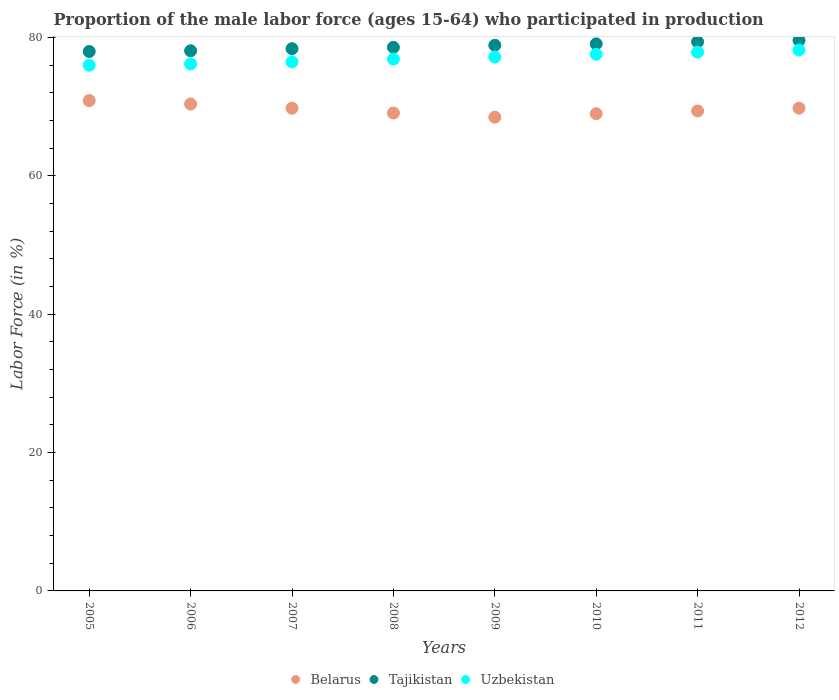What is the proportion of the male labor force who participated in production in Uzbekistan in 2011?
Offer a terse response. 77.9. Across all years, what is the maximum proportion of the male labor force who participated in production in Tajikistan?
Provide a short and direct response. 79.6. Across all years, what is the minimum proportion of the male labor force who participated in production in Belarus?
Provide a short and direct response. 68.5. In which year was the proportion of the male labor force who participated in production in Uzbekistan maximum?
Keep it short and to the point. 2012. In which year was the proportion of the male labor force who participated in production in Tajikistan minimum?
Offer a terse response. 2005. What is the total proportion of the male labor force who participated in production in Belarus in the graph?
Keep it short and to the point. 556.9. What is the difference between the proportion of the male labor force who participated in production in Belarus in 2006 and the proportion of the male labor force who participated in production in Uzbekistan in 2005?
Give a very brief answer. -5.6. What is the average proportion of the male labor force who participated in production in Uzbekistan per year?
Give a very brief answer. 77.06. In the year 2012, what is the difference between the proportion of the male labor force who participated in production in Belarus and proportion of the male labor force who participated in production in Tajikistan?
Provide a short and direct response. -9.8. In how many years, is the proportion of the male labor force who participated in production in Uzbekistan greater than 20 %?
Your answer should be compact. 8. What is the ratio of the proportion of the male labor force who participated in production in Belarus in 2006 to that in 2009?
Your answer should be very brief. 1.03. What is the difference between the highest and the second highest proportion of the male labor force who participated in production in Belarus?
Your response must be concise. 0.5. What is the difference between the highest and the lowest proportion of the male labor force who participated in production in Tajikistan?
Ensure brevity in your answer.  1.6. Is the proportion of the male labor force who participated in production in Belarus strictly less than the proportion of the male labor force who participated in production in Uzbekistan over the years?
Make the answer very short. Yes. How many dotlines are there?
Provide a succinct answer. 3. Does the graph contain grids?
Keep it short and to the point. No. Where does the legend appear in the graph?
Give a very brief answer. Bottom center. What is the title of the graph?
Provide a succinct answer. Proportion of the male labor force (ages 15-64) who participated in production. Does "Azerbaijan" appear as one of the legend labels in the graph?
Your response must be concise. No. What is the label or title of the X-axis?
Ensure brevity in your answer.  Years. What is the Labor Force (in %) in Belarus in 2005?
Offer a very short reply. 70.9. What is the Labor Force (in %) of Tajikistan in 2005?
Your response must be concise. 78. What is the Labor Force (in %) of Belarus in 2006?
Your answer should be very brief. 70.4. What is the Labor Force (in %) in Tajikistan in 2006?
Make the answer very short. 78.1. What is the Labor Force (in %) of Uzbekistan in 2006?
Your answer should be compact. 76.2. What is the Labor Force (in %) of Belarus in 2007?
Ensure brevity in your answer.  69.8. What is the Labor Force (in %) in Tajikistan in 2007?
Ensure brevity in your answer.  78.4. What is the Labor Force (in %) of Uzbekistan in 2007?
Offer a very short reply. 76.5. What is the Labor Force (in %) of Belarus in 2008?
Ensure brevity in your answer.  69.1. What is the Labor Force (in %) of Tajikistan in 2008?
Offer a very short reply. 78.6. What is the Labor Force (in %) in Uzbekistan in 2008?
Give a very brief answer. 76.9. What is the Labor Force (in %) of Belarus in 2009?
Give a very brief answer. 68.5. What is the Labor Force (in %) in Tajikistan in 2009?
Your answer should be very brief. 78.9. What is the Labor Force (in %) of Uzbekistan in 2009?
Your answer should be very brief. 77.2. What is the Labor Force (in %) of Tajikistan in 2010?
Make the answer very short. 79.1. What is the Labor Force (in %) in Uzbekistan in 2010?
Keep it short and to the point. 77.6. What is the Labor Force (in %) of Belarus in 2011?
Your response must be concise. 69.4. What is the Labor Force (in %) of Tajikistan in 2011?
Your answer should be very brief. 79.4. What is the Labor Force (in %) in Uzbekistan in 2011?
Make the answer very short. 77.9. What is the Labor Force (in %) of Belarus in 2012?
Provide a short and direct response. 69.8. What is the Labor Force (in %) in Tajikistan in 2012?
Provide a succinct answer. 79.6. What is the Labor Force (in %) of Uzbekistan in 2012?
Your answer should be very brief. 78.2. Across all years, what is the maximum Labor Force (in %) of Belarus?
Offer a terse response. 70.9. Across all years, what is the maximum Labor Force (in %) of Tajikistan?
Offer a very short reply. 79.6. Across all years, what is the maximum Labor Force (in %) of Uzbekistan?
Make the answer very short. 78.2. Across all years, what is the minimum Labor Force (in %) in Belarus?
Keep it short and to the point. 68.5. Across all years, what is the minimum Labor Force (in %) in Tajikistan?
Give a very brief answer. 78. What is the total Labor Force (in %) of Belarus in the graph?
Your response must be concise. 556.9. What is the total Labor Force (in %) in Tajikistan in the graph?
Your answer should be very brief. 630.1. What is the total Labor Force (in %) of Uzbekistan in the graph?
Your answer should be compact. 616.5. What is the difference between the Labor Force (in %) in Belarus in 2005 and that in 2006?
Your response must be concise. 0.5. What is the difference between the Labor Force (in %) of Tajikistan in 2005 and that in 2006?
Provide a succinct answer. -0.1. What is the difference between the Labor Force (in %) in Uzbekistan in 2005 and that in 2006?
Your answer should be compact. -0.2. What is the difference between the Labor Force (in %) of Belarus in 2005 and that in 2007?
Your answer should be compact. 1.1. What is the difference between the Labor Force (in %) in Uzbekistan in 2005 and that in 2007?
Your answer should be compact. -0.5. What is the difference between the Labor Force (in %) of Belarus in 2005 and that in 2009?
Offer a very short reply. 2.4. What is the difference between the Labor Force (in %) of Tajikistan in 2005 and that in 2009?
Your response must be concise. -0.9. What is the difference between the Labor Force (in %) in Belarus in 2005 and that in 2010?
Your response must be concise. 1.9. What is the difference between the Labor Force (in %) of Uzbekistan in 2005 and that in 2010?
Your answer should be very brief. -1.6. What is the difference between the Labor Force (in %) in Belarus in 2005 and that in 2011?
Ensure brevity in your answer.  1.5. What is the difference between the Labor Force (in %) of Tajikistan in 2005 and that in 2011?
Provide a succinct answer. -1.4. What is the difference between the Labor Force (in %) of Tajikistan in 2005 and that in 2012?
Make the answer very short. -1.6. What is the difference between the Labor Force (in %) of Uzbekistan in 2005 and that in 2012?
Ensure brevity in your answer.  -2.2. What is the difference between the Labor Force (in %) in Uzbekistan in 2006 and that in 2007?
Your response must be concise. -0.3. What is the difference between the Labor Force (in %) of Belarus in 2006 and that in 2008?
Make the answer very short. 1.3. What is the difference between the Labor Force (in %) of Tajikistan in 2006 and that in 2008?
Ensure brevity in your answer.  -0.5. What is the difference between the Labor Force (in %) of Uzbekistan in 2006 and that in 2009?
Your answer should be compact. -1. What is the difference between the Labor Force (in %) of Tajikistan in 2006 and that in 2010?
Give a very brief answer. -1. What is the difference between the Labor Force (in %) of Belarus in 2006 and that in 2011?
Make the answer very short. 1. What is the difference between the Labor Force (in %) of Uzbekistan in 2006 and that in 2011?
Offer a very short reply. -1.7. What is the difference between the Labor Force (in %) in Tajikistan in 2006 and that in 2012?
Give a very brief answer. -1.5. What is the difference between the Labor Force (in %) of Belarus in 2007 and that in 2008?
Your response must be concise. 0.7. What is the difference between the Labor Force (in %) of Uzbekistan in 2007 and that in 2008?
Offer a terse response. -0.4. What is the difference between the Labor Force (in %) of Tajikistan in 2007 and that in 2009?
Your answer should be very brief. -0.5. What is the difference between the Labor Force (in %) of Uzbekistan in 2007 and that in 2009?
Your answer should be very brief. -0.7. What is the difference between the Labor Force (in %) in Tajikistan in 2007 and that in 2010?
Make the answer very short. -0.7. What is the difference between the Labor Force (in %) in Uzbekistan in 2007 and that in 2010?
Your response must be concise. -1.1. What is the difference between the Labor Force (in %) in Uzbekistan in 2007 and that in 2011?
Make the answer very short. -1.4. What is the difference between the Labor Force (in %) of Uzbekistan in 2007 and that in 2012?
Offer a terse response. -1.7. What is the difference between the Labor Force (in %) of Tajikistan in 2008 and that in 2009?
Offer a very short reply. -0.3. What is the difference between the Labor Force (in %) of Belarus in 2008 and that in 2010?
Give a very brief answer. 0.1. What is the difference between the Labor Force (in %) in Tajikistan in 2008 and that in 2010?
Your answer should be compact. -0.5. What is the difference between the Labor Force (in %) in Tajikistan in 2008 and that in 2011?
Ensure brevity in your answer.  -0.8. What is the difference between the Labor Force (in %) in Uzbekistan in 2008 and that in 2012?
Keep it short and to the point. -1.3. What is the difference between the Labor Force (in %) in Belarus in 2009 and that in 2011?
Offer a very short reply. -0.9. What is the difference between the Labor Force (in %) in Tajikistan in 2009 and that in 2011?
Provide a short and direct response. -0.5. What is the difference between the Labor Force (in %) of Uzbekistan in 2009 and that in 2011?
Keep it short and to the point. -0.7. What is the difference between the Labor Force (in %) of Belarus in 2009 and that in 2012?
Offer a very short reply. -1.3. What is the difference between the Labor Force (in %) of Uzbekistan in 2010 and that in 2011?
Provide a succinct answer. -0.3. What is the difference between the Labor Force (in %) of Belarus in 2010 and that in 2012?
Give a very brief answer. -0.8. What is the difference between the Labor Force (in %) of Uzbekistan in 2010 and that in 2012?
Make the answer very short. -0.6. What is the difference between the Labor Force (in %) in Tajikistan in 2011 and that in 2012?
Your response must be concise. -0.2. What is the difference between the Labor Force (in %) of Uzbekistan in 2011 and that in 2012?
Offer a terse response. -0.3. What is the difference between the Labor Force (in %) of Belarus in 2005 and the Labor Force (in %) of Uzbekistan in 2006?
Make the answer very short. -5.3. What is the difference between the Labor Force (in %) in Belarus in 2005 and the Labor Force (in %) in Tajikistan in 2007?
Make the answer very short. -7.5. What is the difference between the Labor Force (in %) in Tajikistan in 2005 and the Labor Force (in %) in Uzbekistan in 2007?
Provide a short and direct response. 1.5. What is the difference between the Labor Force (in %) in Belarus in 2005 and the Labor Force (in %) in Tajikistan in 2008?
Make the answer very short. -7.7. What is the difference between the Labor Force (in %) in Belarus in 2005 and the Labor Force (in %) in Uzbekistan in 2008?
Keep it short and to the point. -6. What is the difference between the Labor Force (in %) of Belarus in 2005 and the Labor Force (in %) of Tajikistan in 2010?
Make the answer very short. -8.2. What is the difference between the Labor Force (in %) in Belarus in 2005 and the Labor Force (in %) in Uzbekistan in 2010?
Ensure brevity in your answer.  -6.7. What is the difference between the Labor Force (in %) of Tajikistan in 2005 and the Labor Force (in %) of Uzbekistan in 2010?
Provide a succinct answer. 0.4. What is the difference between the Labor Force (in %) in Belarus in 2005 and the Labor Force (in %) in Tajikistan in 2011?
Provide a short and direct response. -8.5. What is the difference between the Labor Force (in %) in Belarus in 2005 and the Labor Force (in %) in Tajikistan in 2012?
Provide a short and direct response. -8.7. What is the difference between the Labor Force (in %) in Belarus in 2005 and the Labor Force (in %) in Uzbekistan in 2012?
Keep it short and to the point. -7.3. What is the difference between the Labor Force (in %) in Tajikistan in 2006 and the Labor Force (in %) in Uzbekistan in 2008?
Make the answer very short. 1.2. What is the difference between the Labor Force (in %) in Tajikistan in 2006 and the Labor Force (in %) in Uzbekistan in 2009?
Give a very brief answer. 0.9. What is the difference between the Labor Force (in %) of Belarus in 2006 and the Labor Force (in %) of Tajikistan in 2010?
Offer a terse response. -8.7. What is the difference between the Labor Force (in %) of Belarus in 2006 and the Labor Force (in %) of Uzbekistan in 2010?
Provide a succinct answer. -7.2. What is the difference between the Labor Force (in %) of Belarus in 2006 and the Labor Force (in %) of Tajikistan in 2011?
Ensure brevity in your answer.  -9. What is the difference between the Labor Force (in %) of Tajikistan in 2006 and the Labor Force (in %) of Uzbekistan in 2011?
Provide a succinct answer. 0.2. What is the difference between the Labor Force (in %) of Tajikistan in 2006 and the Labor Force (in %) of Uzbekistan in 2012?
Your answer should be compact. -0.1. What is the difference between the Labor Force (in %) of Belarus in 2007 and the Labor Force (in %) of Tajikistan in 2008?
Your answer should be compact. -8.8. What is the difference between the Labor Force (in %) in Belarus in 2007 and the Labor Force (in %) in Tajikistan in 2009?
Your response must be concise. -9.1. What is the difference between the Labor Force (in %) of Tajikistan in 2007 and the Labor Force (in %) of Uzbekistan in 2009?
Provide a succinct answer. 1.2. What is the difference between the Labor Force (in %) of Belarus in 2007 and the Labor Force (in %) of Uzbekistan in 2010?
Your answer should be compact. -7.8. What is the difference between the Labor Force (in %) in Tajikistan in 2007 and the Labor Force (in %) in Uzbekistan in 2010?
Give a very brief answer. 0.8. What is the difference between the Labor Force (in %) in Belarus in 2007 and the Labor Force (in %) in Tajikistan in 2011?
Your answer should be very brief. -9.6. What is the difference between the Labor Force (in %) of Belarus in 2007 and the Labor Force (in %) of Uzbekistan in 2011?
Make the answer very short. -8.1. What is the difference between the Labor Force (in %) in Belarus in 2007 and the Labor Force (in %) in Uzbekistan in 2012?
Provide a succinct answer. -8.4. What is the difference between the Labor Force (in %) in Belarus in 2008 and the Labor Force (in %) in Uzbekistan in 2009?
Make the answer very short. -8.1. What is the difference between the Labor Force (in %) in Tajikistan in 2008 and the Labor Force (in %) in Uzbekistan in 2009?
Ensure brevity in your answer.  1.4. What is the difference between the Labor Force (in %) in Belarus in 2008 and the Labor Force (in %) in Tajikistan in 2010?
Your answer should be very brief. -10. What is the difference between the Labor Force (in %) in Belarus in 2008 and the Labor Force (in %) in Uzbekistan in 2010?
Keep it short and to the point. -8.5. What is the difference between the Labor Force (in %) in Tajikistan in 2008 and the Labor Force (in %) in Uzbekistan in 2010?
Provide a succinct answer. 1. What is the difference between the Labor Force (in %) of Tajikistan in 2008 and the Labor Force (in %) of Uzbekistan in 2011?
Your response must be concise. 0.7. What is the difference between the Labor Force (in %) in Belarus in 2008 and the Labor Force (in %) in Tajikistan in 2012?
Your answer should be very brief. -10.5. What is the difference between the Labor Force (in %) of Belarus in 2008 and the Labor Force (in %) of Uzbekistan in 2012?
Offer a terse response. -9.1. What is the difference between the Labor Force (in %) in Belarus in 2009 and the Labor Force (in %) in Uzbekistan in 2010?
Offer a very short reply. -9.1. What is the difference between the Labor Force (in %) of Belarus in 2010 and the Labor Force (in %) of Tajikistan in 2011?
Ensure brevity in your answer.  -10.4. What is the difference between the Labor Force (in %) of Tajikistan in 2010 and the Labor Force (in %) of Uzbekistan in 2011?
Provide a succinct answer. 1.2. What is the difference between the Labor Force (in %) of Tajikistan in 2010 and the Labor Force (in %) of Uzbekistan in 2012?
Provide a short and direct response. 0.9. What is the average Labor Force (in %) in Belarus per year?
Keep it short and to the point. 69.61. What is the average Labor Force (in %) of Tajikistan per year?
Make the answer very short. 78.76. What is the average Labor Force (in %) in Uzbekistan per year?
Offer a very short reply. 77.06. In the year 2005, what is the difference between the Labor Force (in %) in Belarus and Labor Force (in %) in Tajikistan?
Make the answer very short. -7.1. In the year 2005, what is the difference between the Labor Force (in %) in Belarus and Labor Force (in %) in Uzbekistan?
Your response must be concise. -5.1. In the year 2005, what is the difference between the Labor Force (in %) of Tajikistan and Labor Force (in %) of Uzbekistan?
Offer a terse response. 2. In the year 2006, what is the difference between the Labor Force (in %) of Belarus and Labor Force (in %) of Uzbekistan?
Your response must be concise. -5.8. In the year 2007, what is the difference between the Labor Force (in %) in Belarus and Labor Force (in %) in Uzbekistan?
Ensure brevity in your answer.  -6.7. In the year 2007, what is the difference between the Labor Force (in %) in Tajikistan and Labor Force (in %) in Uzbekistan?
Offer a very short reply. 1.9. In the year 2008, what is the difference between the Labor Force (in %) of Belarus and Labor Force (in %) of Uzbekistan?
Offer a very short reply. -7.8. In the year 2008, what is the difference between the Labor Force (in %) of Tajikistan and Labor Force (in %) of Uzbekistan?
Make the answer very short. 1.7. In the year 2009, what is the difference between the Labor Force (in %) in Tajikistan and Labor Force (in %) in Uzbekistan?
Offer a terse response. 1.7. In the year 2010, what is the difference between the Labor Force (in %) in Belarus and Labor Force (in %) in Tajikistan?
Provide a succinct answer. -10.1. In the year 2010, what is the difference between the Labor Force (in %) in Belarus and Labor Force (in %) in Uzbekistan?
Keep it short and to the point. -8.6. In the year 2011, what is the difference between the Labor Force (in %) of Tajikistan and Labor Force (in %) of Uzbekistan?
Provide a short and direct response. 1.5. What is the ratio of the Labor Force (in %) of Belarus in 2005 to that in 2006?
Offer a very short reply. 1.01. What is the ratio of the Labor Force (in %) in Belarus in 2005 to that in 2007?
Keep it short and to the point. 1.02. What is the ratio of the Labor Force (in %) of Uzbekistan in 2005 to that in 2007?
Provide a succinct answer. 0.99. What is the ratio of the Labor Force (in %) of Belarus in 2005 to that in 2008?
Offer a terse response. 1.03. What is the ratio of the Labor Force (in %) in Uzbekistan in 2005 to that in 2008?
Offer a terse response. 0.99. What is the ratio of the Labor Force (in %) of Belarus in 2005 to that in 2009?
Provide a short and direct response. 1.03. What is the ratio of the Labor Force (in %) of Tajikistan in 2005 to that in 2009?
Offer a very short reply. 0.99. What is the ratio of the Labor Force (in %) in Uzbekistan in 2005 to that in 2009?
Your answer should be very brief. 0.98. What is the ratio of the Labor Force (in %) of Belarus in 2005 to that in 2010?
Give a very brief answer. 1.03. What is the ratio of the Labor Force (in %) in Tajikistan in 2005 to that in 2010?
Your answer should be compact. 0.99. What is the ratio of the Labor Force (in %) of Uzbekistan in 2005 to that in 2010?
Your response must be concise. 0.98. What is the ratio of the Labor Force (in %) of Belarus in 2005 to that in 2011?
Ensure brevity in your answer.  1.02. What is the ratio of the Labor Force (in %) in Tajikistan in 2005 to that in 2011?
Your answer should be compact. 0.98. What is the ratio of the Labor Force (in %) of Uzbekistan in 2005 to that in 2011?
Your answer should be compact. 0.98. What is the ratio of the Labor Force (in %) in Belarus in 2005 to that in 2012?
Offer a very short reply. 1.02. What is the ratio of the Labor Force (in %) of Tajikistan in 2005 to that in 2012?
Give a very brief answer. 0.98. What is the ratio of the Labor Force (in %) of Uzbekistan in 2005 to that in 2012?
Provide a succinct answer. 0.97. What is the ratio of the Labor Force (in %) in Belarus in 2006 to that in 2007?
Your answer should be compact. 1.01. What is the ratio of the Labor Force (in %) in Belarus in 2006 to that in 2008?
Offer a very short reply. 1.02. What is the ratio of the Labor Force (in %) of Uzbekistan in 2006 to that in 2008?
Offer a terse response. 0.99. What is the ratio of the Labor Force (in %) in Belarus in 2006 to that in 2009?
Offer a very short reply. 1.03. What is the ratio of the Labor Force (in %) of Uzbekistan in 2006 to that in 2009?
Ensure brevity in your answer.  0.99. What is the ratio of the Labor Force (in %) of Belarus in 2006 to that in 2010?
Offer a very short reply. 1.02. What is the ratio of the Labor Force (in %) of Tajikistan in 2006 to that in 2010?
Your answer should be compact. 0.99. What is the ratio of the Labor Force (in %) in Belarus in 2006 to that in 2011?
Your answer should be compact. 1.01. What is the ratio of the Labor Force (in %) in Tajikistan in 2006 to that in 2011?
Provide a short and direct response. 0.98. What is the ratio of the Labor Force (in %) of Uzbekistan in 2006 to that in 2011?
Give a very brief answer. 0.98. What is the ratio of the Labor Force (in %) of Belarus in 2006 to that in 2012?
Your answer should be compact. 1.01. What is the ratio of the Labor Force (in %) in Tajikistan in 2006 to that in 2012?
Keep it short and to the point. 0.98. What is the ratio of the Labor Force (in %) in Uzbekistan in 2006 to that in 2012?
Your answer should be compact. 0.97. What is the ratio of the Labor Force (in %) in Belarus in 2007 to that in 2008?
Your answer should be compact. 1.01. What is the ratio of the Labor Force (in %) of Tajikistan in 2007 to that in 2008?
Your answer should be compact. 1. What is the ratio of the Labor Force (in %) in Belarus in 2007 to that in 2009?
Provide a short and direct response. 1.02. What is the ratio of the Labor Force (in %) of Uzbekistan in 2007 to that in 2009?
Provide a succinct answer. 0.99. What is the ratio of the Labor Force (in %) of Belarus in 2007 to that in 2010?
Provide a short and direct response. 1.01. What is the ratio of the Labor Force (in %) of Uzbekistan in 2007 to that in 2010?
Make the answer very short. 0.99. What is the ratio of the Labor Force (in %) in Belarus in 2007 to that in 2011?
Your answer should be very brief. 1.01. What is the ratio of the Labor Force (in %) of Tajikistan in 2007 to that in 2011?
Keep it short and to the point. 0.99. What is the ratio of the Labor Force (in %) in Uzbekistan in 2007 to that in 2011?
Your answer should be very brief. 0.98. What is the ratio of the Labor Force (in %) in Belarus in 2007 to that in 2012?
Offer a very short reply. 1. What is the ratio of the Labor Force (in %) in Tajikistan in 2007 to that in 2012?
Provide a succinct answer. 0.98. What is the ratio of the Labor Force (in %) in Uzbekistan in 2007 to that in 2012?
Ensure brevity in your answer.  0.98. What is the ratio of the Labor Force (in %) of Belarus in 2008 to that in 2009?
Your answer should be very brief. 1.01. What is the ratio of the Labor Force (in %) of Tajikistan in 2008 to that in 2009?
Provide a short and direct response. 1. What is the ratio of the Labor Force (in %) of Uzbekistan in 2008 to that in 2010?
Provide a short and direct response. 0.99. What is the ratio of the Labor Force (in %) of Belarus in 2008 to that in 2011?
Make the answer very short. 1. What is the ratio of the Labor Force (in %) in Tajikistan in 2008 to that in 2011?
Your response must be concise. 0.99. What is the ratio of the Labor Force (in %) of Uzbekistan in 2008 to that in 2011?
Ensure brevity in your answer.  0.99. What is the ratio of the Labor Force (in %) of Tajikistan in 2008 to that in 2012?
Your response must be concise. 0.99. What is the ratio of the Labor Force (in %) in Uzbekistan in 2008 to that in 2012?
Keep it short and to the point. 0.98. What is the ratio of the Labor Force (in %) of Belarus in 2009 to that in 2010?
Give a very brief answer. 0.99. What is the ratio of the Labor Force (in %) in Belarus in 2009 to that in 2011?
Offer a terse response. 0.99. What is the ratio of the Labor Force (in %) in Tajikistan in 2009 to that in 2011?
Offer a terse response. 0.99. What is the ratio of the Labor Force (in %) in Belarus in 2009 to that in 2012?
Your answer should be compact. 0.98. What is the ratio of the Labor Force (in %) in Uzbekistan in 2009 to that in 2012?
Your response must be concise. 0.99. What is the ratio of the Labor Force (in %) in Belarus in 2010 to that in 2011?
Make the answer very short. 0.99. What is the ratio of the Labor Force (in %) of Tajikistan in 2010 to that in 2011?
Offer a terse response. 1. What is the ratio of the Labor Force (in %) in Belarus in 2010 to that in 2012?
Provide a succinct answer. 0.99. What is the ratio of the Labor Force (in %) in Tajikistan in 2010 to that in 2012?
Offer a terse response. 0.99. What is the ratio of the Labor Force (in %) of Uzbekistan in 2010 to that in 2012?
Your answer should be very brief. 0.99. What is the difference between the highest and the second highest Labor Force (in %) in Belarus?
Your answer should be very brief. 0.5. 